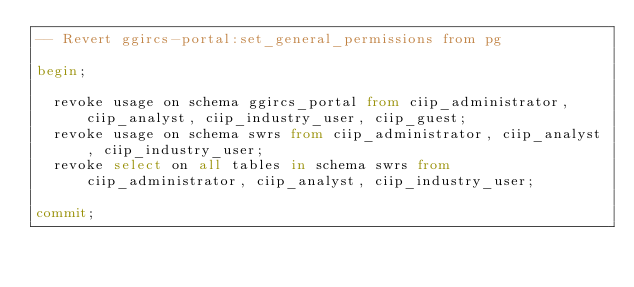Convert code to text. <code><loc_0><loc_0><loc_500><loc_500><_SQL_>-- Revert ggircs-portal:set_general_permissions from pg

begin;

  revoke usage on schema ggircs_portal from ciip_administrator, ciip_analyst, ciip_industry_user, ciip_guest;
  revoke usage on schema swrs from ciip_administrator, ciip_analyst, ciip_industry_user;
  revoke select on all tables in schema swrs from ciip_administrator, ciip_analyst, ciip_industry_user;

commit;
</code> 